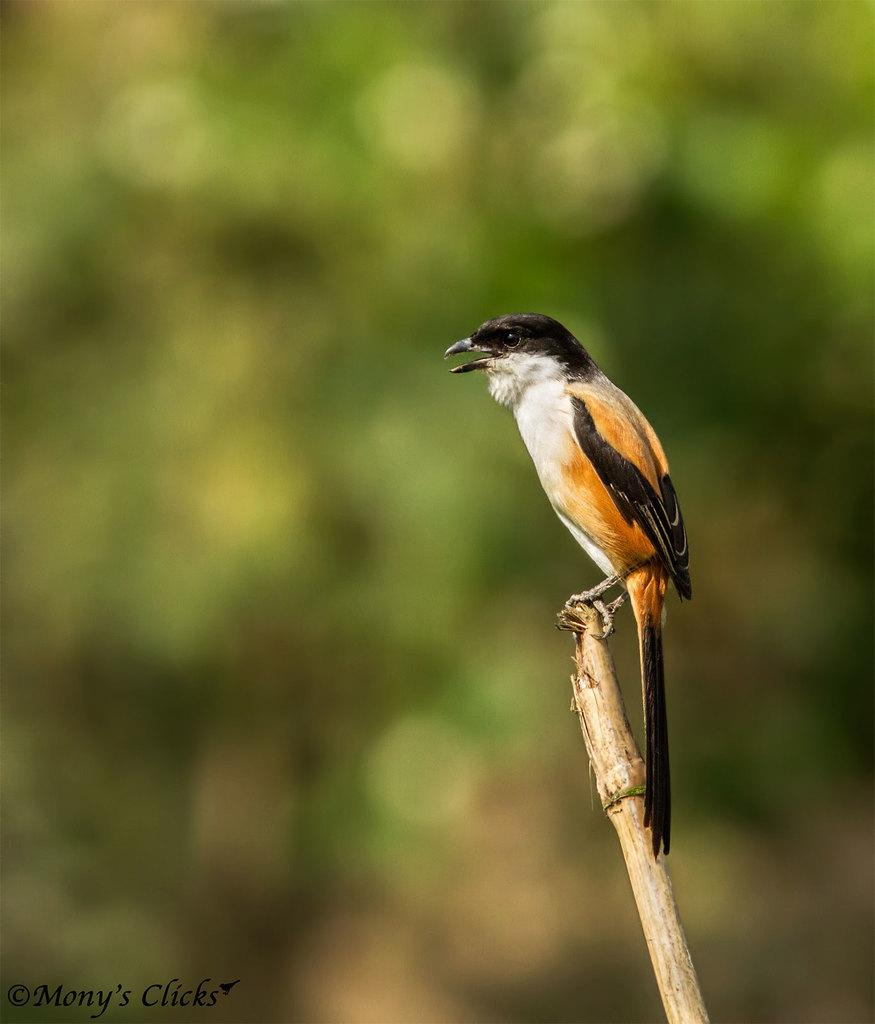What type of animal is in the image? There is a bird in the image. What is the bird standing on? The bird is standing on a stick. Can you describe the background of the image? The background of the image is blurred. What is present in the bottom left corner of the image? There is text in the bottom left corner of the image. What type of design is the worm using to process the bird's feathers in the image? There is no worm present in the image, and therefore no such design or process can be observed. 